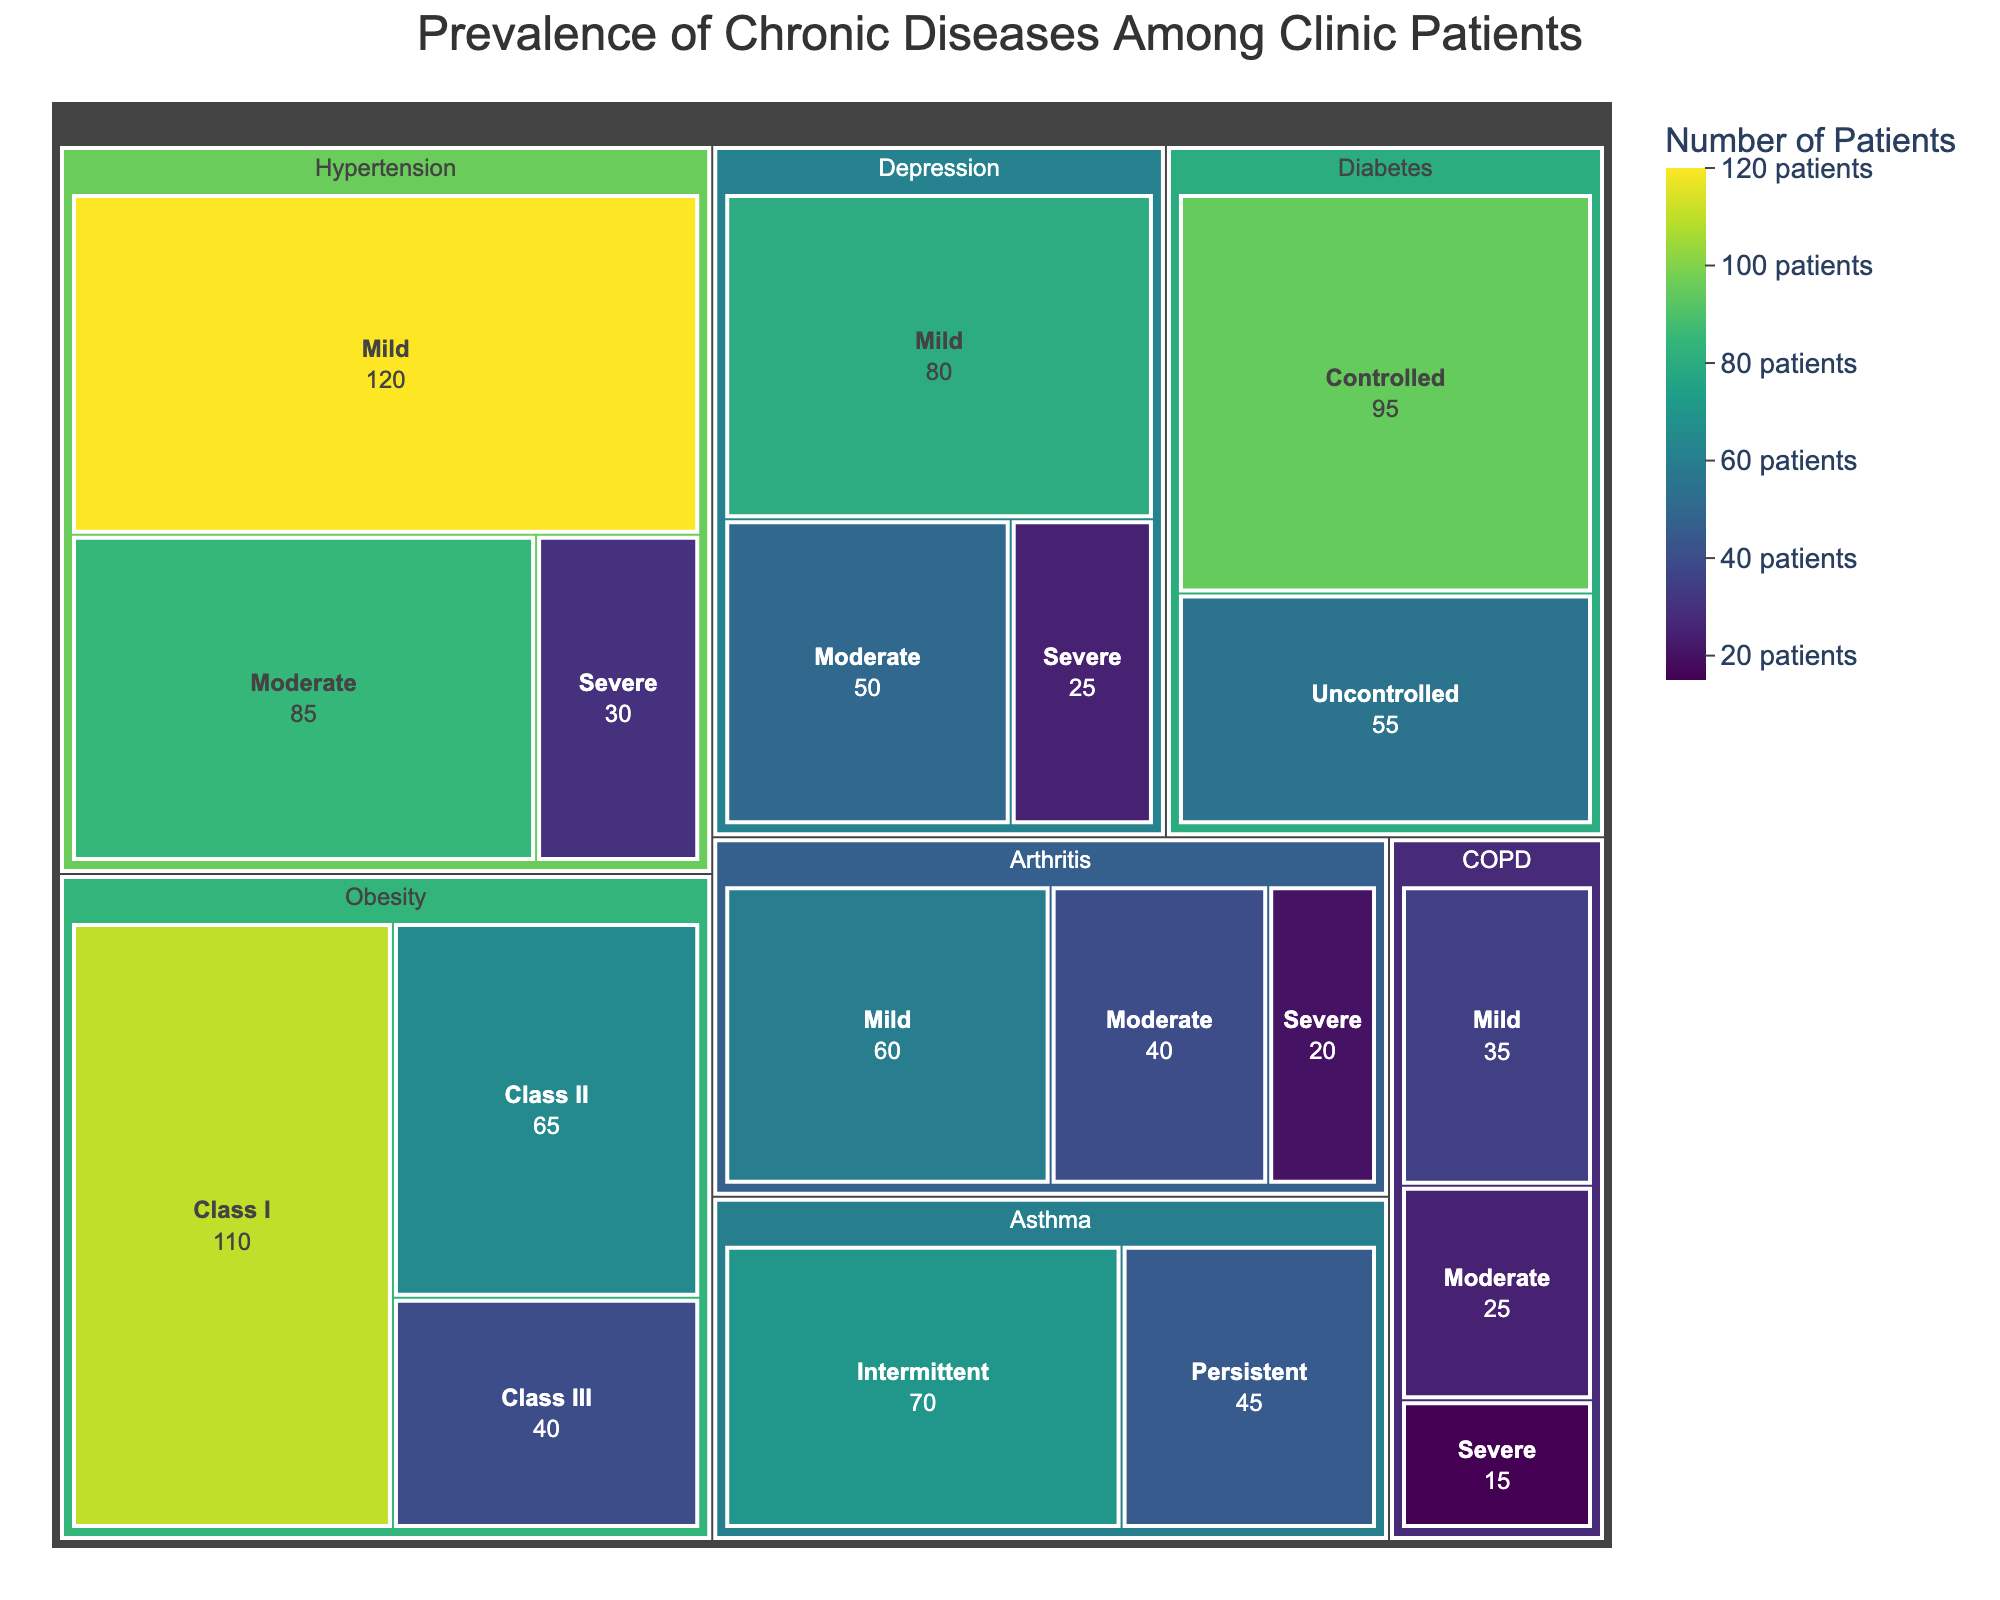What is the title of the treemap figure? The title is usually displayed at the top center of the figure. It sets the context for what the figure represents, which in this case will be insightful for your clinic-based needs.
Answer: Prevalence of Chronic Diseases Among Clinic Patients Which chronic condition has the highest number of patients in mild severity? From the treemap, you can identify the number of patients for each condition and severity by looking at the size of the corresponding tiles. The largest mild severity tile represents the highest number.
Answer: Hypertension What is the total number of patients with Diabetes? To find the total number of Diabetes patients, add the values from all severity categories for Diabetes: Controlled and Uncontrolled. Adding these numbers gives the total.
Answer: 150 Which condition has more patients in severe severity, COPD or Arthritis? Compare the number of patients in the severe category for COPD and Arthritis by referring to the size and value shown in the tiles for these conditions.
Answer: Arthritis How many patients suffer from Obesity across all severity levels? Sum the patient numbers for all the severity levels of Obesity: Class I, Class II, and Class III. This sum gives the total number of Obesity patients.
Answer: 215 Which condition has the least number of patients overall? Review the overall size of the conditions by summing all severity levels and compare them. The condition with the smallest total will be the least prevalent.
Answer: COPD Which condition has more patients overall, Asthma or Depression? Sum the number of patients for all severity levels in Asthma and then do the same for Depression. Comparing these totals will show which condition has more patients.
Answer: Depression What is the most prevalent severity level for Hypertension? For Hypertension, compare the patient numbers across Mild, Moderate, and Severe severity levels. The level with the highest number is the most prevalent.
Answer: Mild How many more patients have Mild Hypertension compared to Severe Obesity (Class III)? Identify the number of patients in Mild Hypertension and Severe Obesity (Class III) and calculate the difference between them.
Answer: 80 Which conditions have more than one severity level with fewer than 50 patients each? Examine the treemap for conditions that have at least two severity levels where each level has fewer than 50 patients. List those conditions.
Answer: COPD, Arthritis 